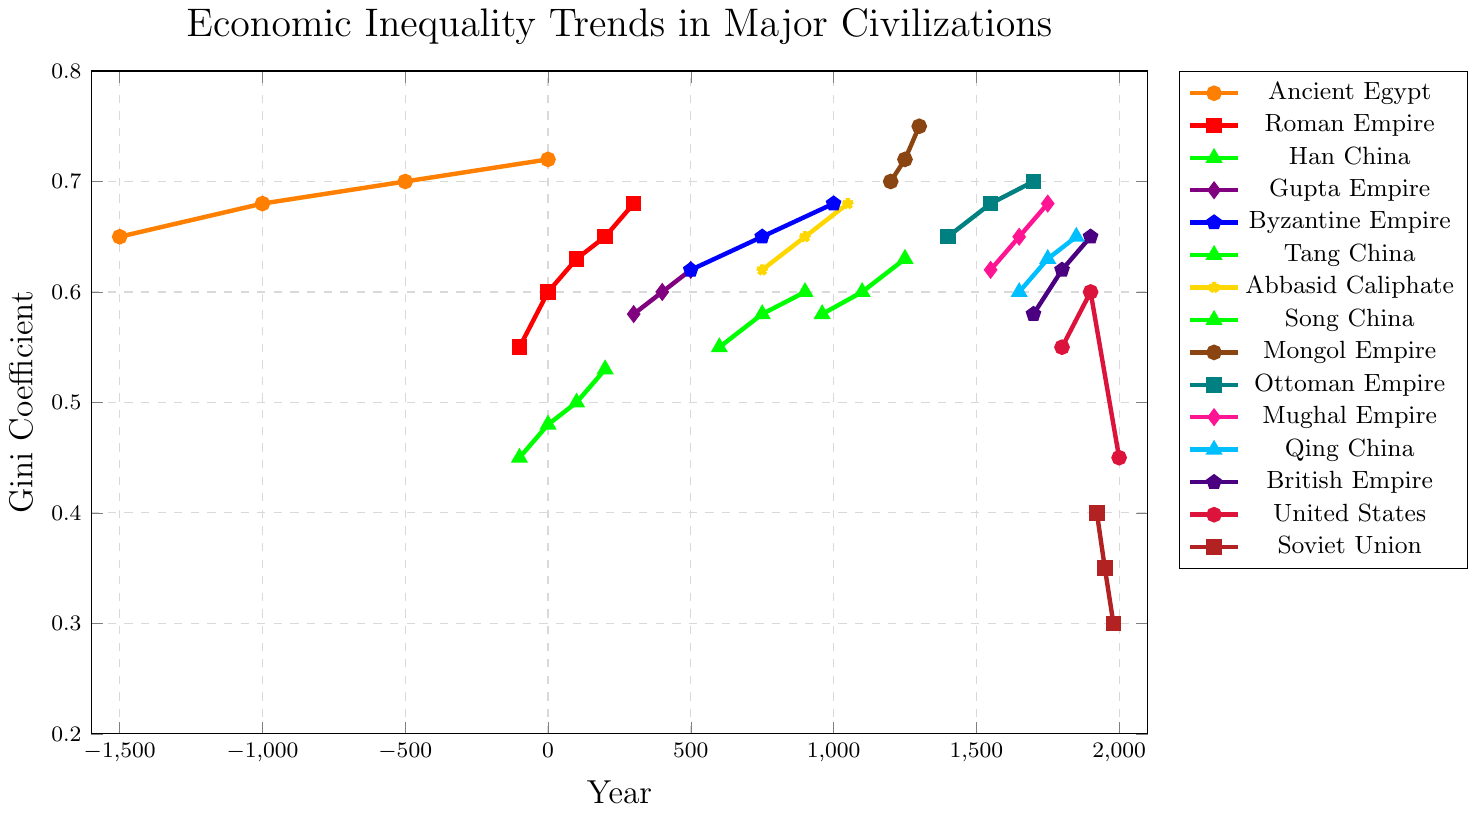What trend do we observe in the Gini Coefficient of Ancient Egypt from -1500 to 0? Ancient Egypt has four data points: -1500 (0.65), -1000 (0.68), -500 (0.70), and 0 (0.72). Each value is increasing over time, indicating a trend of rising economic inequality.
Answer: Rising inequality How does the economic inequality in the Soviet Union change from 1922 to 1980? The data points for the Soviet Union are 1922 (0.40), 1950 (0.35), and 1980 (0.30). Each value decreases over time, indicating a decreasing trend in economic inequality.
Answer: Decreasing inequality Which civilization has the highest Gini Coefficient around the year 1250, and what is its value? The civilizations with data around 1250 are the Song China (1250, 0.63) and the Mongol Empire (1250, 0.72). Among these, the Mongol Empire has the highest value.
Answer: Mongol Empire, 0.72 Compare the Gini Coefficient of the United States in 1800 and 2000. Which year has a higher value? The data points for the United States are 1800 (0.55) and 2000 (0.45). The value is higher in 1800 compared to 2000.
Answer: 1800 What are the Gini Coefficients of Han China over time, and what is the average? The Gini Coefficients for Han China are -100 (0.45), 0 (0.48), 100 (0.50), and 200 (0.53). The sum of these values is 0.45 + 0.48 + 0.50 + 0.53 = 1.96. The average is 1.96 / 4.
Answer: 0.49 What is the difference in the Gini Coefficient of the British Empire between 1700 and 1800? The data points for the British Empire are 1700 (0.58) and 1800 (0.62). The difference is 0.62 - 0.58.
Answer: 0.04 Which civilization has the lowest Gini Coefficient, and what is its value? The lowest value in the dataset is for the Soviet Union in 1980, which is 0.30.
Answer: Soviet Union, 0.30 How do the Gini Coefficients of the Mongol Empire change between 1200 and 1300? The data points for the Mongol Empire are 1200 (0.70), 1250 (0.72), and 1300 (0.75). Each value increases, indicating a rising trend in economic inequality.
Answer: Rising inequality 